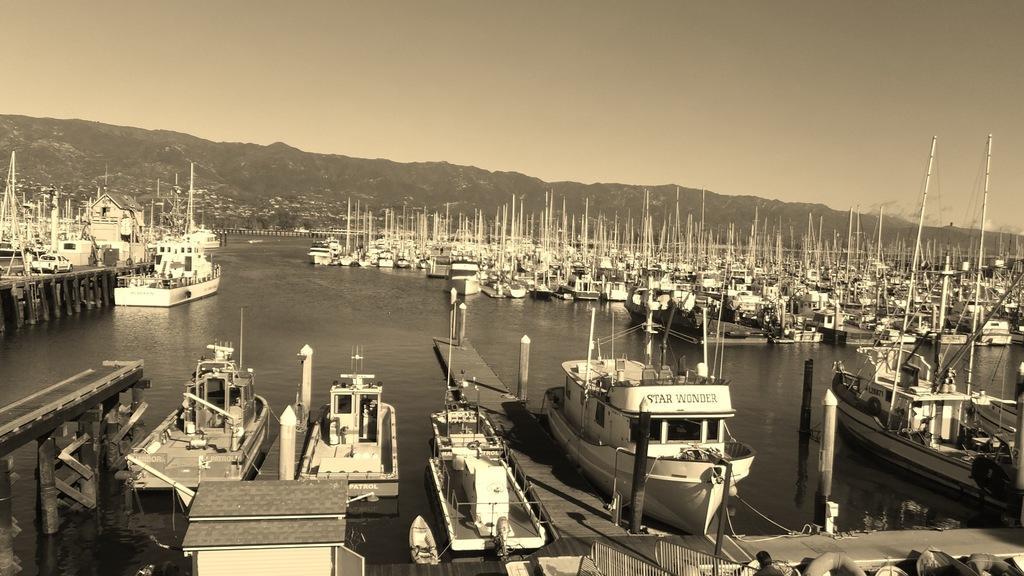Describe this image in one or two sentences. In this image we can see boats, water. In the background of the image there are mountains, trees. At the top of the image there is sky. 